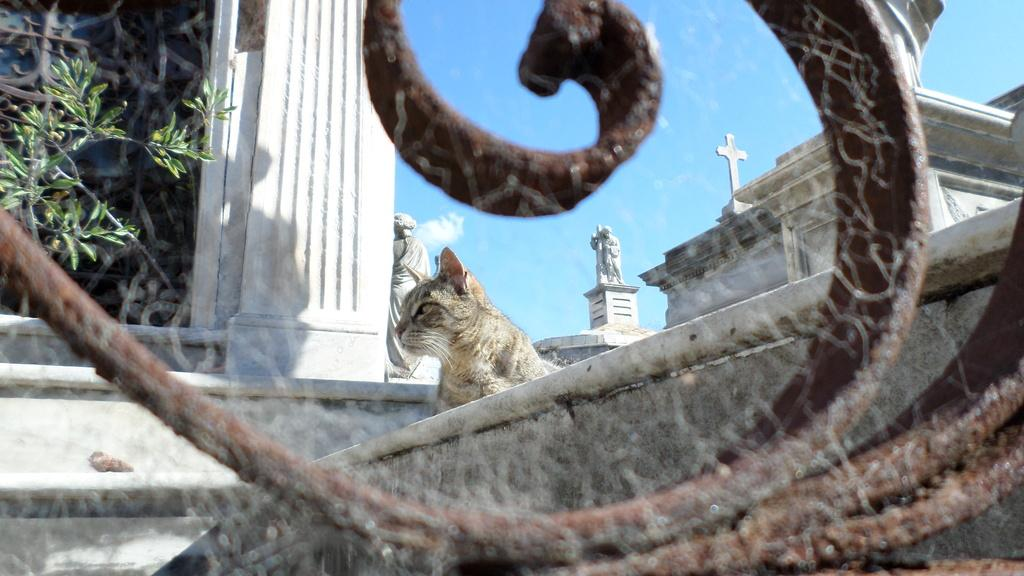What is the brown object in the front of the image? There is an object in the front of the image, and it is brown in color. What is located in the center of the image? There is a cat in the center of the image. What can be seen in the background of the image? There are statues, a plant, and a wall in the background of the image. Where is the sofa located in the image? There is no sofa present in the image. What type of ornament is hanging from the wall in the image? There is no ornament mentioned in the image; only the wall is mentioned in the background. 